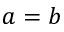Convert formula to latex. <formula><loc_0><loc_0><loc_500><loc_500>a = b</formula> 